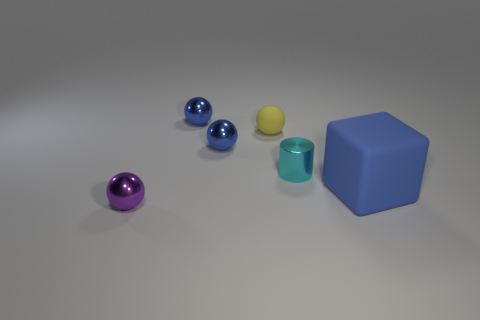Add 2 tiny brown metal things. How many objects exist? 8 Subtract all balls. How many objects are left? 2 Subtract 1 blue cubes. How many objects are left? 5 Subtract all small green metallic balls. Subtract all small purple metal balls. How many objects are left? 5 Add 5 big things. How many big things are left? 6 Add 3 metal things. How many metal things exist? 7 